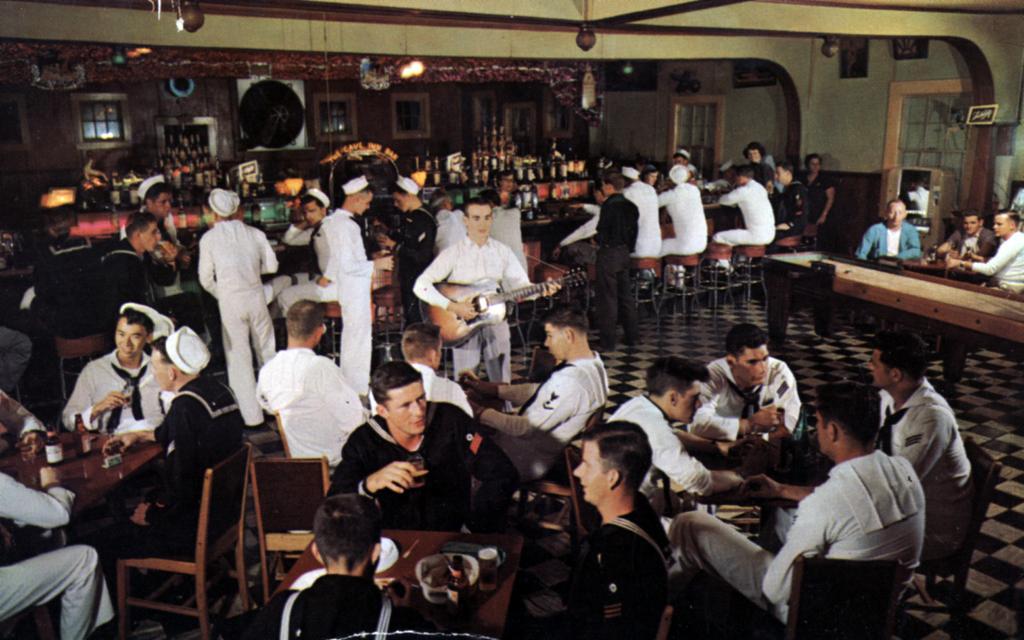Could you give a brief overview of what you see in this image? In this picture I can observe some people sitting in the chairs in front of their respective tables. Most of them are men. I can observe a person playing guitar in the middle of the picture. In the background there is a wall. 